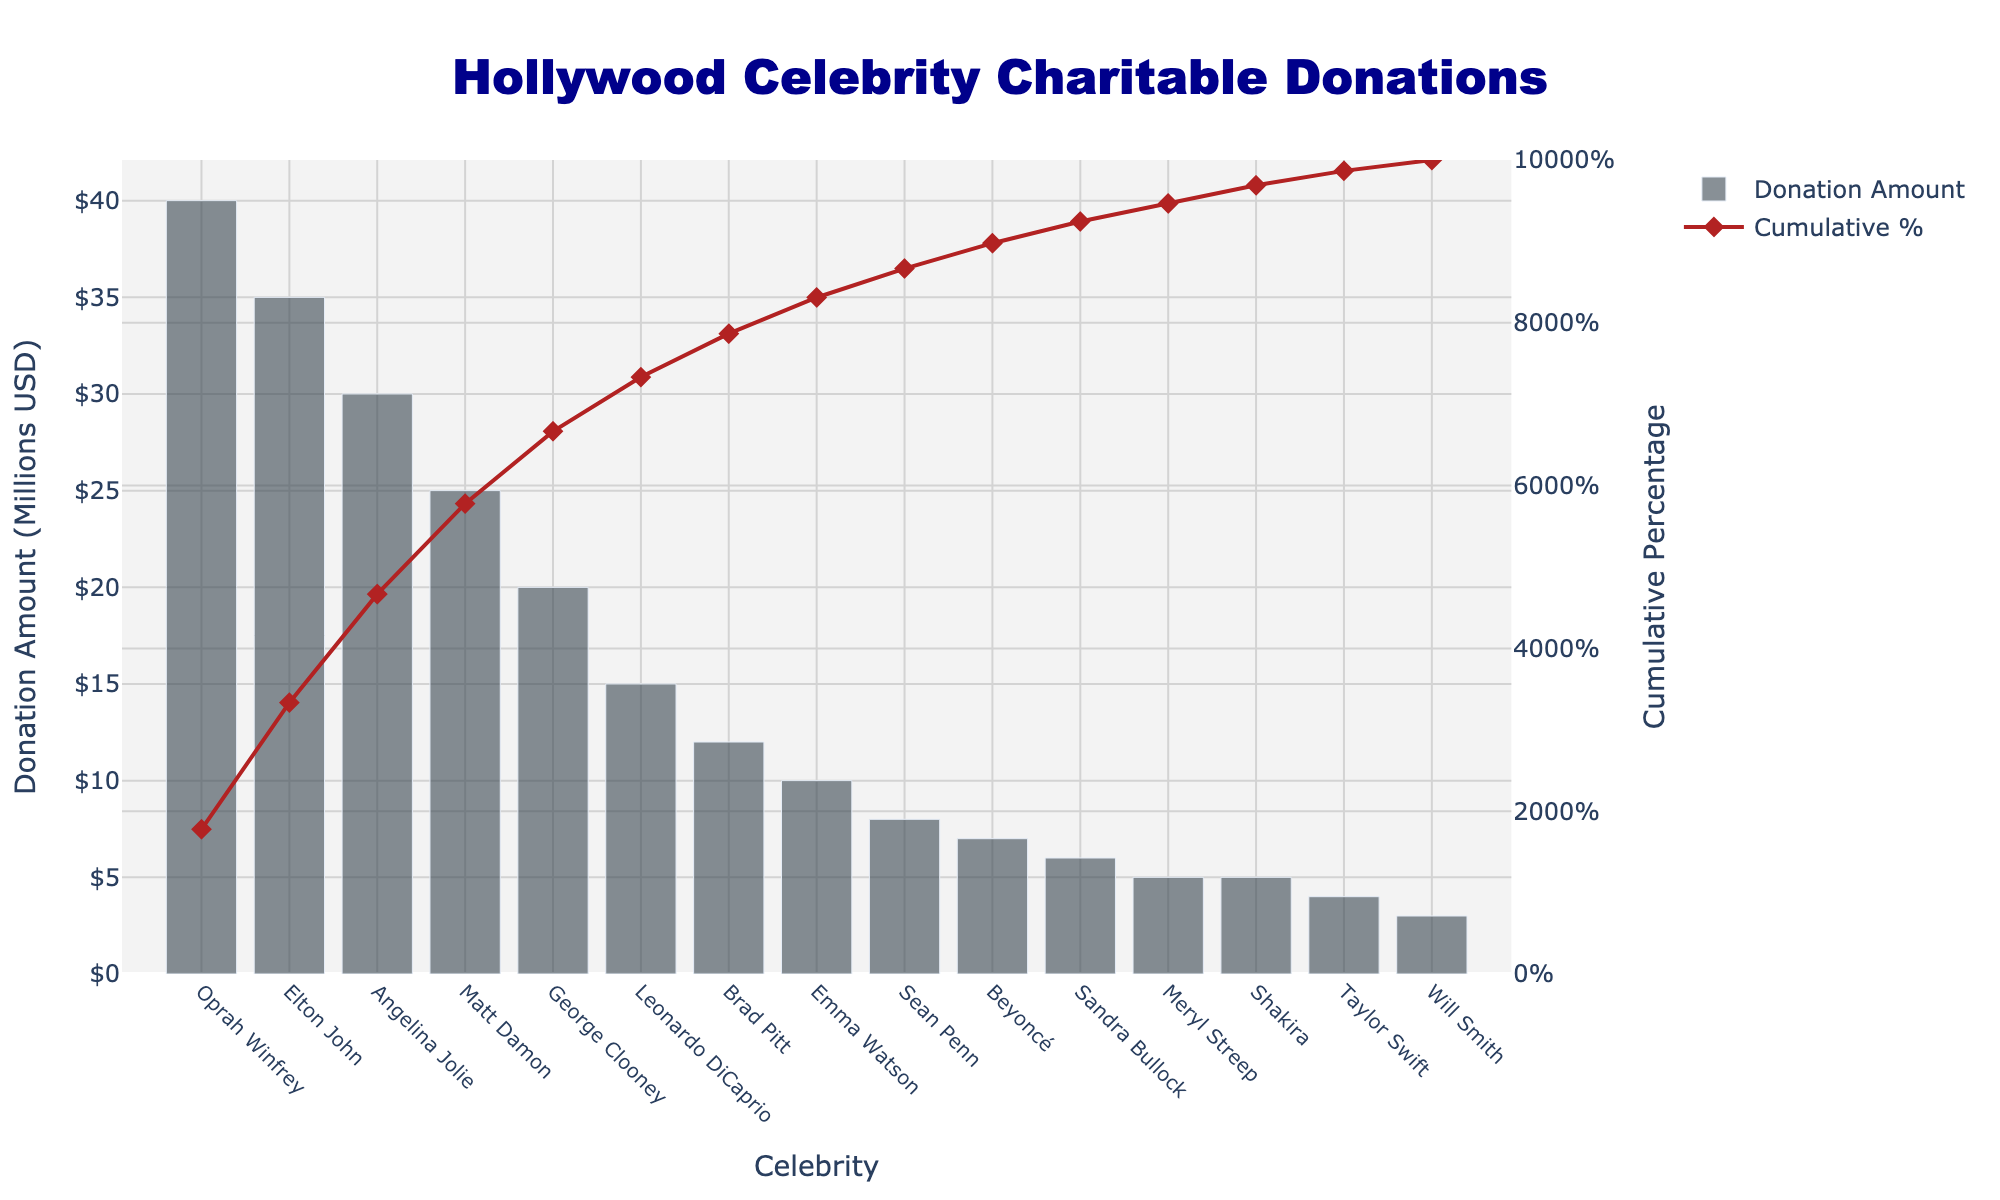Who donated the most amount of money? The tallest bar in the bar chart represents the largest donation amount. According to the height of the bars, Oprah Winfrey has the tallest bar.
Answer: Oprah Winfrey What cause did Leonardo DiCaprio donate to? Look for the bar labeled "Leonardo DiCaprio". The hover template should show the donation amount and the associated cause.
Answer: Environmental Conservation How much money was donated by the top three donors combined? The top three donors by donation amount are Oprah Winfrey, Elton John, and Angelina Jolie. Their donations are 40, 35, and 30 million USD respectively. The sum is 40 + 35 + 30 million USD.
Answer: 105 million USD What is the cumulative percentage after Matt Damon's donation? Find the bar for Matt Damon and refer to the cumulative percentage line that matches. After Matt Damon's donation, the cumulative percentage is about 80%.
Answer: 80% Who donated more, Beyoncé or Taylor Swift? Compare the height of Beyoncé's bar to Taylor Swift's bar. Beyoncé's bar is taller than Taylor Swift's bar, indicating a higher donation amount.
Answer: Beyoncé What is the difference in donation amount between Brad Pitt and George Clooney? Find the bars for Brad Pitt (12 million USD) and George Clooney (20 million USD). The difference is 20 - 12 million USD.
Answer: 8 million USD Which celebrity's donation amounts to around 10% of the total donations? Use the cumulative percentage line to identify the celebrity whose donation matches approximately with 10% mark. Emma Watson donated around 10% of the total.
Answer: Emma Watson How many celebrities donated more than 15 million USD? Count the number of bars taller than 15 million USD. The celebrities are Oprah Winfrey, Elton John, Angelina Jolie, Leonardo DiCaprio, and Matt Damon.
Answer: 5 Which two causes received the smallest donations, and who donated to them? Identify the two shortest bars on the bar chart. The two smallest donations are Will Smith (Youth Development) and Taylor Swift (Music Education).
Answer: Youth Development (Will Smith), Music Education (Taylor Swift) What is the average donation amount of the top five donors? The top five donors are Oprah Winfrey, Elton John, Angelina Jolie, Leonardo DiCaprio, and Matt Damon. Their donation amounts are 40, 35, 30, 15, and 25 million USD respectively. The sum is 40 + 35 + 30 + 15 + 25 = 145 million USD. The average is 145 / 5.
Answer: 29 million USD 